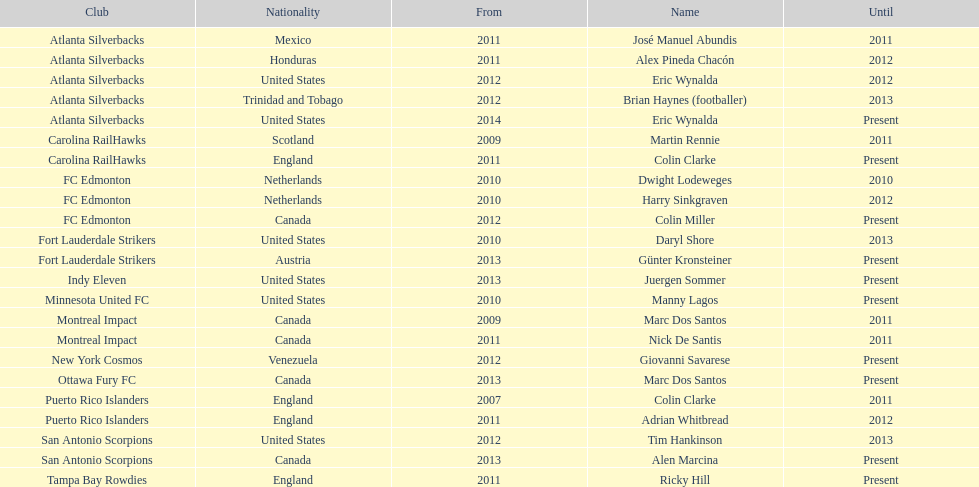What same country did marc dos santos coach as colin miller? Canada. 